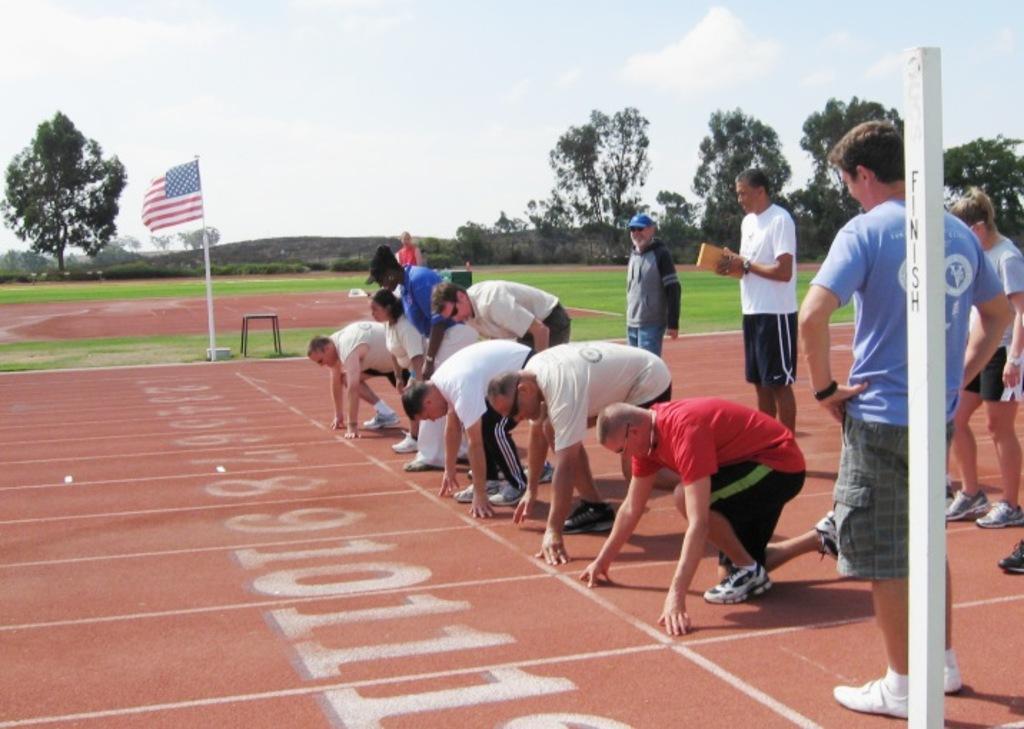Describe this image in one or two sentences. In this image on the right side we can see few persons are standing and few persons are bending and we can see few persons are in squat position on the ground and we can see a pole. In the background there is a flag, trees and grass on the ground and clouds in the sky. 